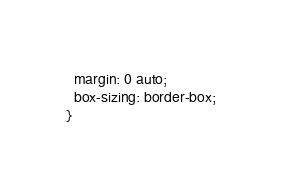<code> <loc_0><loc_0><loc_500><loc_500><_CSS_>  margin: 0 auto;
  box-sizing: border-box;
}</code> 